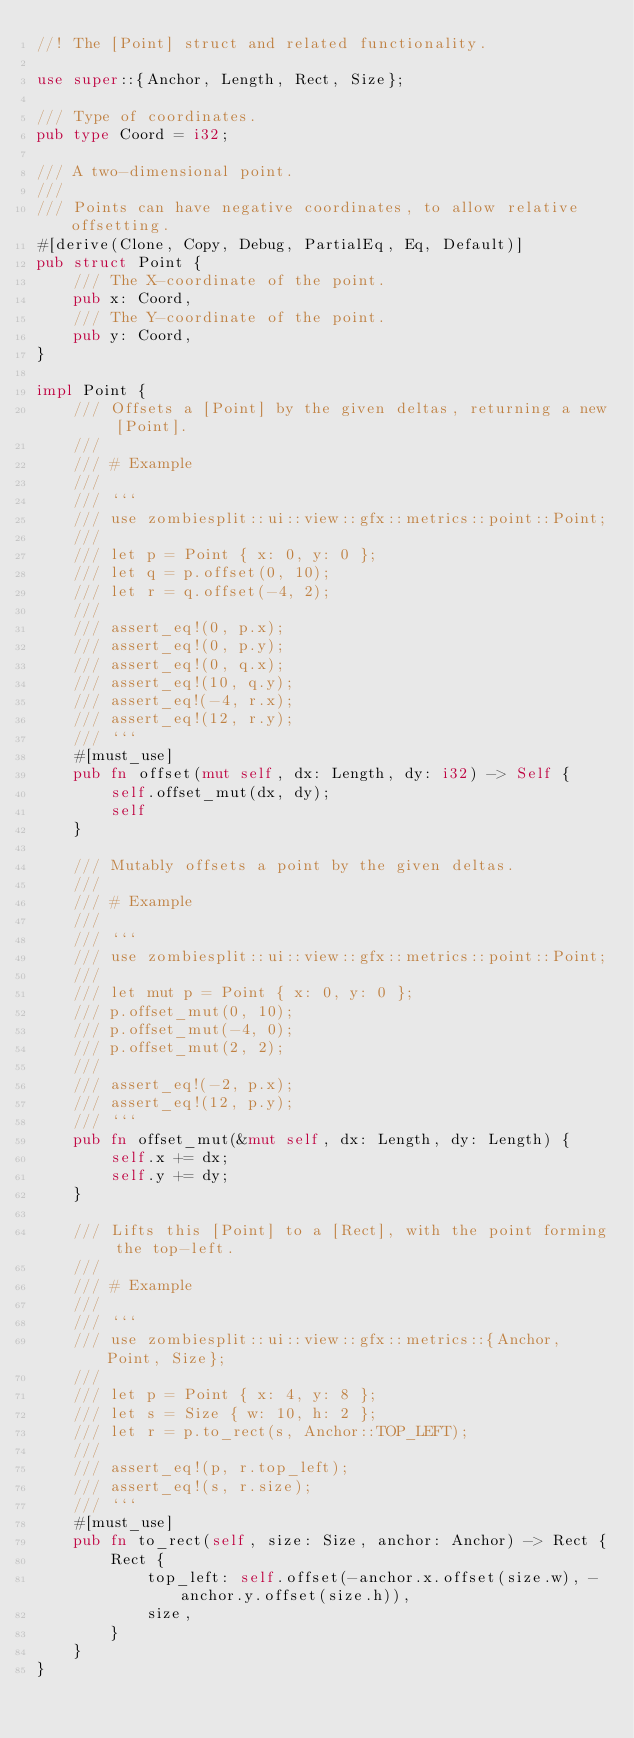Convert code to text. <code><loc_0><loc_0><loc_500><loc_500><_Rust_>//! The [Point] struct and related functionality.

use super::{Anchor, Length, Rect, Size};

/// Type of coordinates.
pub type Coord = i32;

/// A two-dimensional point.
///
/// Points can have negative coordinates, to allow relative offsetting.
#[derive(Clone, Copy, Debug, PartialEq, Eq, Default)]
pub struct Point {
    /// The X-coordinate of the point.
    pub x: Coord,
    /// The Y-coordinate of the point.
    pub y: Coord,
}

impl Point {
    /// Offsets a [Point] by the given deltas, returning a new [Point].
    ///
    /// # Example
    ///
    /// ```
    /// use zombiesplit::ui::view::gfx::metrics::point::Point;
    ///
    /// let p = Point { x: 0, y: 0 };
    /// let q = p.offset(0, 10);
    /// let r = q.offset(-4, 2);
    ///
    /// assert_eq!(0, p.x);
    /// assert_eq!(0, p.y);
    /// assert_eq!(0, q.x);
    /// assert_eq!(10, q.y);
    /// assert_eq!(-4, r.x);
    /// assert_eq!(12, r.y);
    /// ```
    #[must_use]
    pub fn offset(mut self, dx: Length, dy: i32) -> Self {
        self.offset_mut(dx, dy);
        self
    }

    /// Mutably offsets a point by the given deltas.
    ///
    /// # Example
    ///
    /// ```
    /// use zombiesplit::ui::view::gfx::metrics::point::Point;
    ///
    /// let mut p = Point { x: 0, y: 0 };
    /// p.offset_mut(0, 10);
    /// p.offset_mut(-4, 0);
    /// p.offset_mut(2, 2);
    ///
    /// assert_eq!(-2, p.x);
    /// assert_eq!(12, p.y);
    /// ```
    pub fn offset_mut(&mut self, dx: Length, dy: Length) {
        self.x += dx;
        self.y += dy;
    }

    /// Lifts this [Point] to a [Rect], with the point forming the top-left.
    ///
    /// # Example
    ///
    /// ```
    /// use zombiesplit::ui::view::gfx::metrics::{Anchor, Point, Size};
    ///
    /// let p = Point { x: 4, y: 8 };
    /// let s = Size { w: 10, h: 2 };
    /// let r = p.to_rect(s, Anchor::TOP_LEFT);
    ///
    /// assert_eq!(p, r.top_left);
    /// assert_eq!(s, r.size);
    /// ```
    #[must_use]
    pub fn to_rect(self, size: Size, anchor: Anchor) -> Rect {
        Rect {
            top_left: self.offset(-anchor.x.offset(size.w), -anchor.y.offset(size.h)),
            size,
        }
    }
}
</code> 